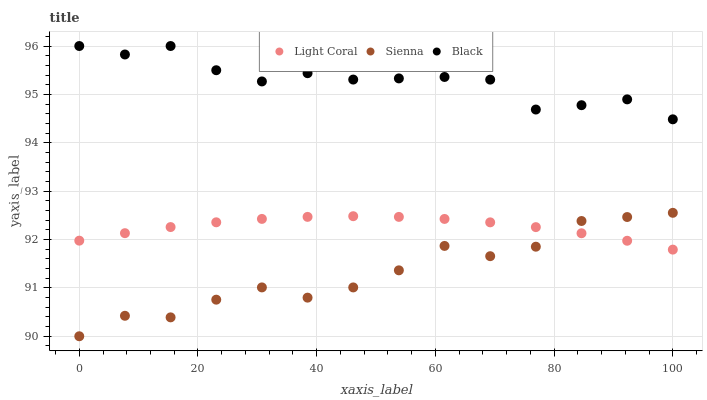Does Sienna have the minimum area under the curve?
Answer yes or no. Yes. Does Black have the maximum area under the curve?
Answer yes or no. Yes. Does Black have the minimum area under the curve?
Answer yes or no. No. Does Sienna have the maximum area under the curve?
Answer yes or no. No. Is Light Coral the smoothest?
Answer yes or no. Yes. Is Black the roughest?
Answer yes or no. Yes. Is Sienna the smoothest?
Answer yes or no. No. Is Sienna the roughest?
Answer yes or no. No. Does Sienna have the lowest value?
Answer yes or no. Yes. Does Black have the lowest value?
Answer yes or no. No. Does Black have the highest value?
Answer yes or no. Yes. Does Sienna have the highest value?
Answer yes or no. No. Is Light Coral less than Black?
Answer yes or no. Yes. Is Black greater than Light Coral?
Answer yes or no. Yes. Does Light Coral intersect Sienna?
Answer yes or no. Yes. Is Light Coral less than Sienna?
Answer yes or no. No. Is Light Coral greater than Sienna?
Answer yes or no. No. Does Light Coral intersect Black?
Answer yes or no. No. 